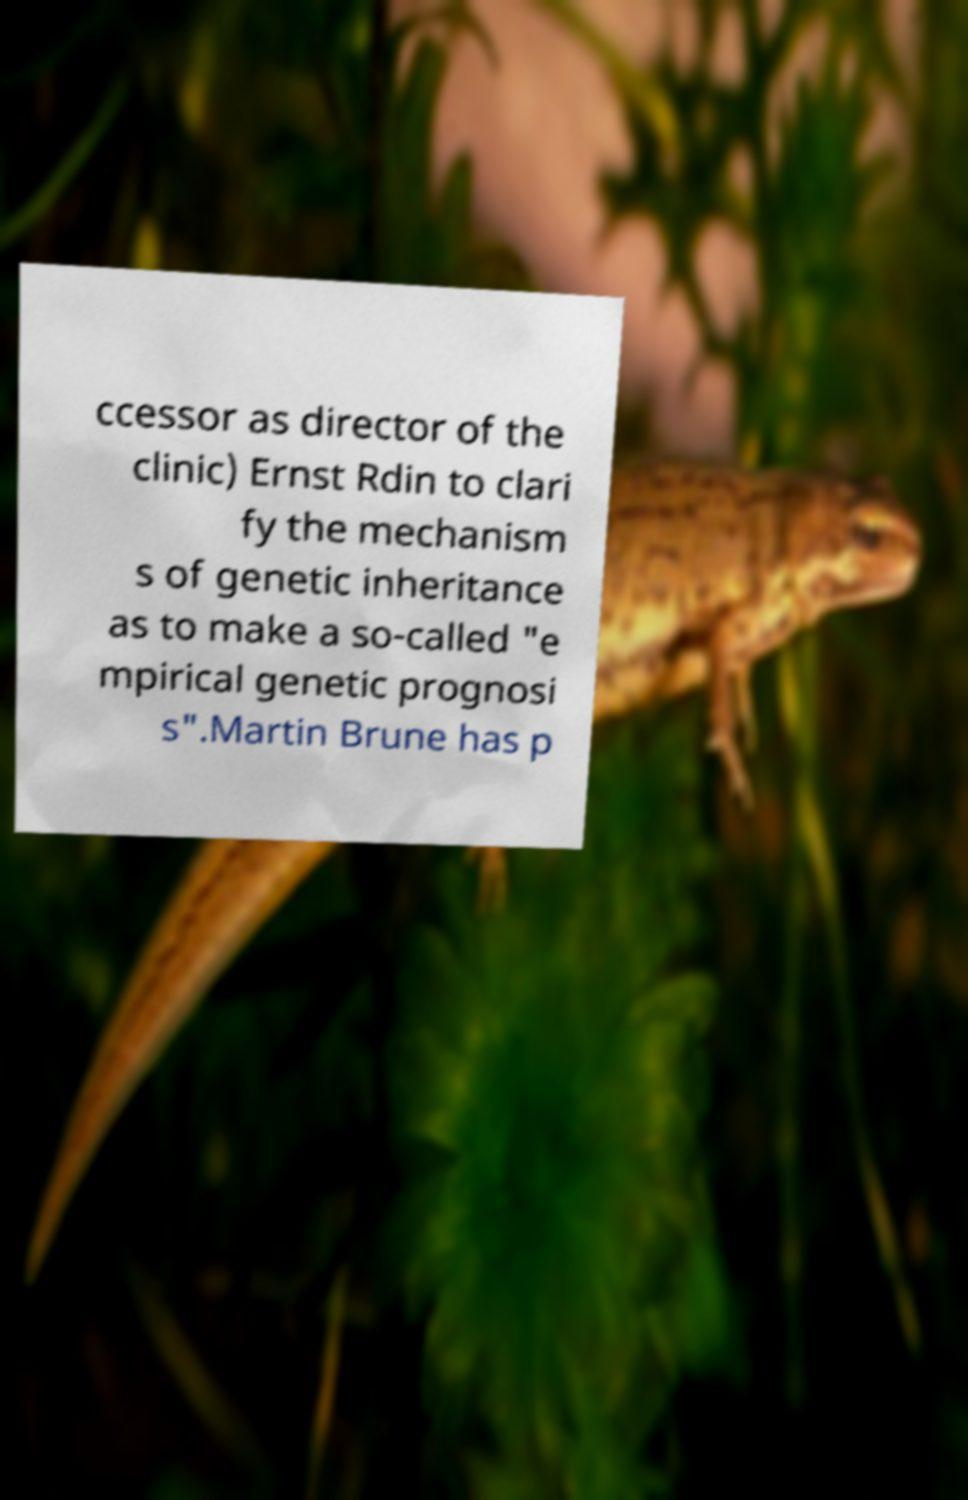What messages or text are displayed in this image? I need them in a readable, typed format. ccessor as director of the clinic) Ernst Rdin to clari fy the mechanism s of genetic inheritance as to make a so-called "e mpirical genetic prognosi s".Martin Brune has p 